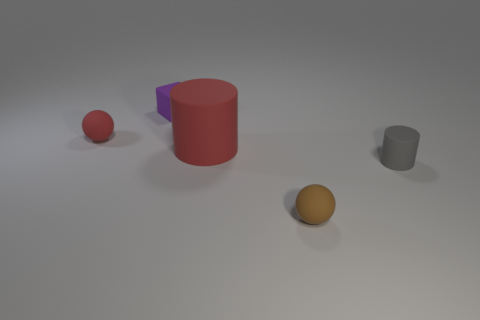Subtract 1 balls. How many balls are left? 1 Add 5 large cylinders. How many objects exist? 10 Subtract all red balls. How many balls are left? 1 Subtract all balls. How many objects are left? 3 Subtract 1 gray cylinders. How many objects are left? 4 Subtract all cyan balls. Subtract all green cubes. How many balls are left? 2 Subtract all green cubes. Subtract all purple cubes. How many objects are left? 4 Add 4 gray matte cylinders. How many gray matte cylinders are left? 5 Add 3 tiny purple rubber objects. How many tiny purple rubber objects exist? 4 